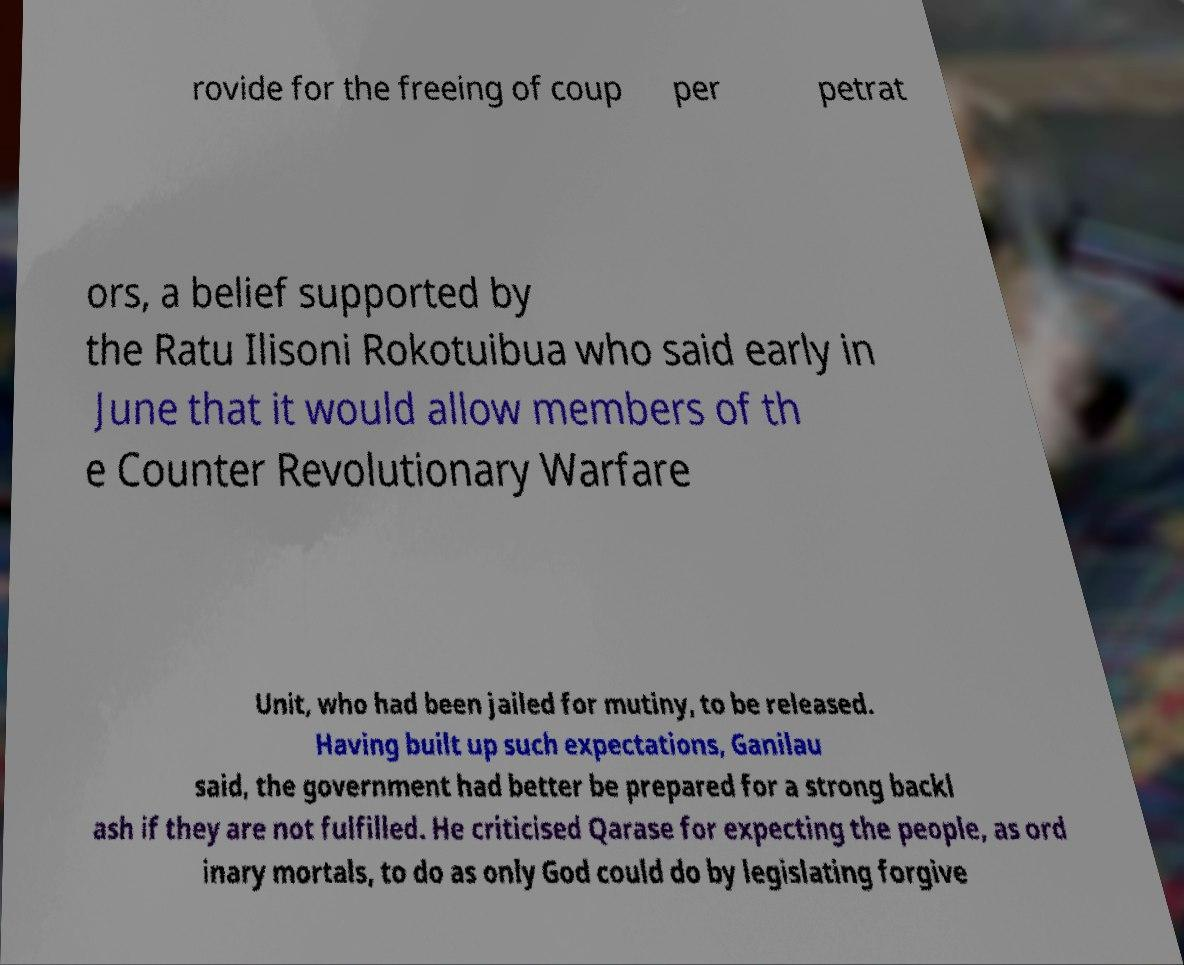Can you accurately transcribe the text from the provided image for me? rovide for the freeing of coup per petrat ors, a belief supported by the Ratu Ilisoni Rokotuibua who said early in June that it would allow members of th e Counter Revolutionary Warfare Unit, who had been jailed for mutiny, to be released. Having built up such expectations, Ganilau said, the government had better be prepared for a strong backl ash if they are not fulfilled. He criticised Qarase for expecting the people, as ord inary mortals, to do as only God could do by legislating forgive 